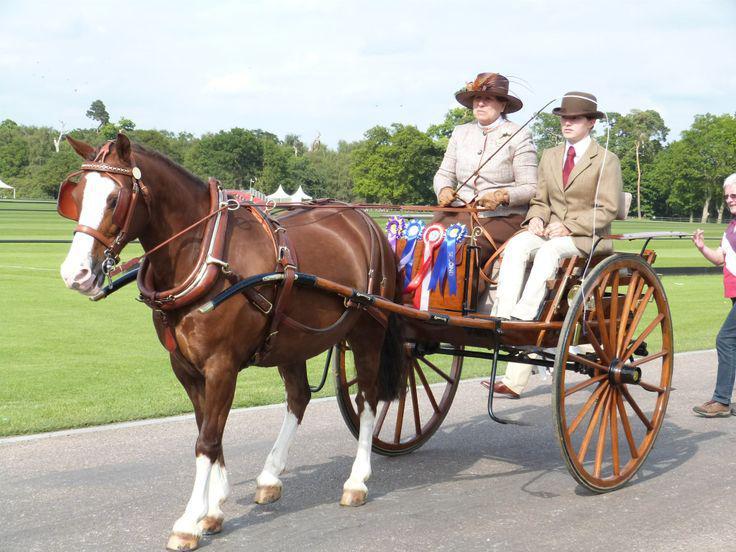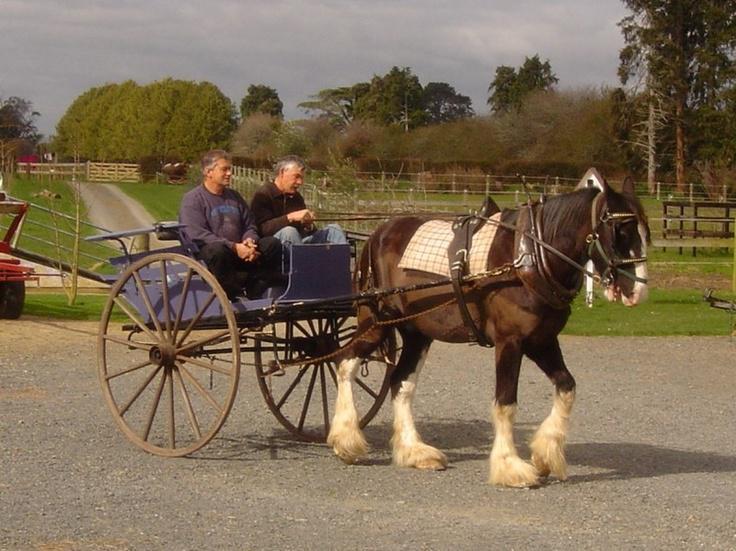The first image is the image on the left, the second image is the image on the right. For the images displayed, is the sentence "At least one wagon is carrying more than one person." factually correct? Answer yes or no. Yes. The first image is the image on the left, the second image is the image on the right. Assess this claim about the two images: "The carriages are being pulled by brown horses.". Correct or not? Answer yes or no. Yes. 